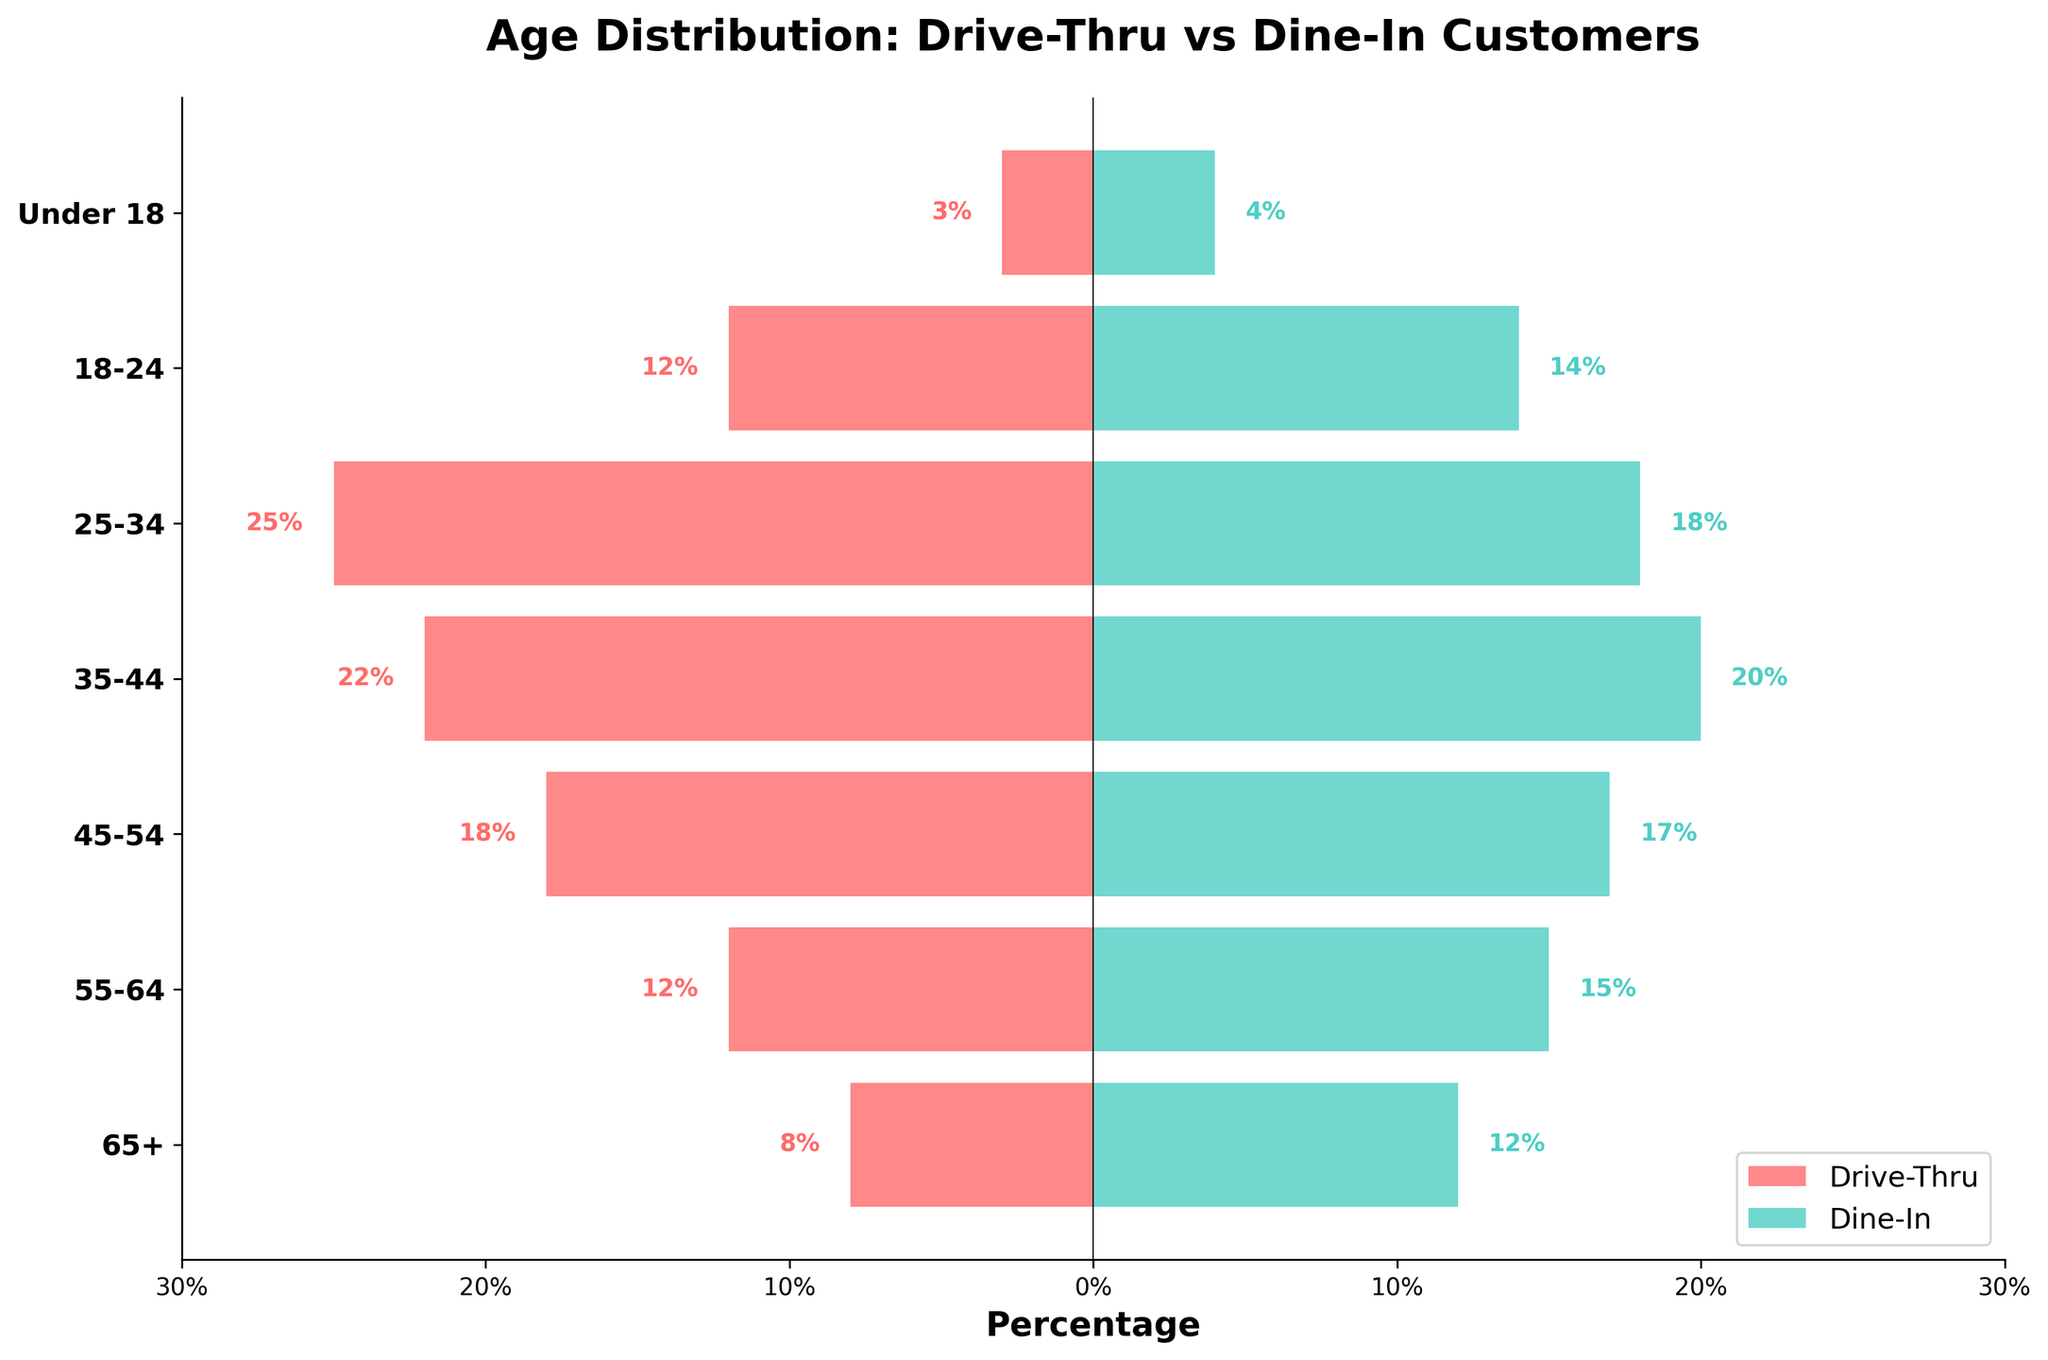What is the title of the figure? The title of the figure is located at the top of the plot. It gives us an overview of what the chart represents. By reading the title at the top, we can see it states, "Age Distribution: Drive-Thru vs Dine-In Customers."
Answer: Age Distribution: Drive-Thru vs Dine-In Customers Which age group has the highest percentage of drive-thru customers? To find the age group with the highest percentage of drive-thru customers, look at the horizontal bars on the left side of the pyramid and identify the longest bar. The longest bar on the left corresponds to the "25-34" age group with 25%.
Answer: 25-34 Which age group has a higher percentage of dine-in customers compared to drive-thru customers? Compare the lengths of horizontal bars for each age group on both sides of the chart. The age group "65+" has a higher percentage of dine-in customers (12%) compared to drive-thru customers (8%).
Answer: 65+ What is the percentage difference of dine-in customers between the age groups 25-34 and 18-24? Find the percentages of dine-in customers for both age groups from the bars on the right. The percentage for "25-34" is 18%, and for "18-24", it is 14%. Subtract the percentage for "18-24" from "25-34" to get the difference: 18% - 14% = 4%.
Answer: 4% Which age group has the least percentage for both drive-thru and dine-in customers? Identify the shortest bars on both sides of the chart. For both drive-thru and dine-in customers, the "Under 18" age group has the least percentages, with 3% for drive-thru and 4% for dine-in.
Answer: Under 18 What is the sum of the percentages of drive-thru customers for age groups 45-54 and 55-64? Find the percentages of drive-thru customers for each age group and then add them together: For age group "45-54" it is 18%, and for age group "55-64" it is 12%. The sum is 18% + 12% = 30%.
Answer: 30% What is the percentage difference between drive-thru and dine-in customers in the 35-44 age group? Find the percentages for both drive-thru and dine-in customers in the "35-44" age group. Drive-thru is 22% and dine-in is 20%. The difference is 22% - 20% = 2%.
Answer: 2% Which age group shows nearly equal percentages for drive-thru and dine-in customers? Look for age groups where the lengths of the bars on both sides are almost equal. The "45-54" age group has nearly equal percentages with 18% for drive-thru and 17% for dine-in.
Answer: 45-54 What can be inferred about customer preferences based on their age? By analyzing the overall trend in the plotted data, we observe how older age groups (65+ and 55-64) prefer dine-in over drive-thru, while younger age groups (25-34) strongly prefer drive-thru over dine-in. Generally, younger adults show a higher preference for drive-thru while older adults show a higher preference for dine-in.
Answer: Younger adults prefer drive-thru, older adults prefer dine-in Based on the figure, which side has a higher total percentage across all age groups: drive-thru or dine-in? Calculate the total percentage for drive-thru and dine-in by summing the percentages across all age groups for each. Drive-thru: 8+12+18+22+25+12+3 = 100. Dine-in: 12+15+17+20+18+14+4 = 100. Both drive-thru and dine-in have the same total percentage of 100%.
Answer: Both have 100% 